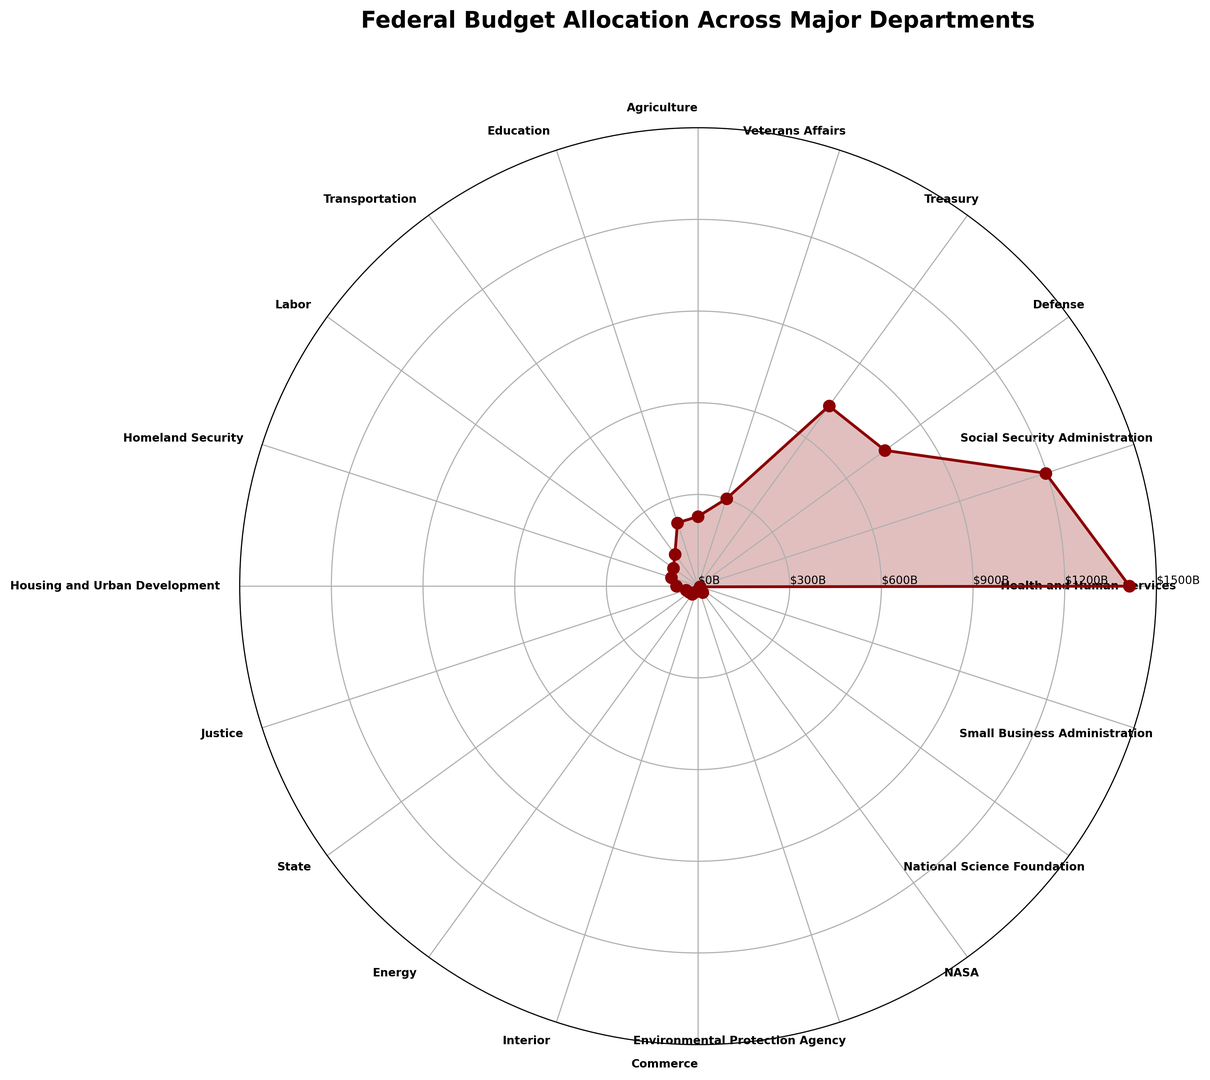Which department has the highest budget allocation? By examining the plot, the department with the largest radial segment will have the highest budget allocation. Health and Human Services has the biggest segment.
Answer: Health and Human Services How does the budget of the Defense department compare to that of the Treasury? Locate both Defense and Treasury segments in the plot and compare their lengths. The Defense radial segment is slightly longer than Treasury's.
Answer: Defense is greater Which two departments have the smallest budget allocations? Look for the smallest radial segments, which represent the smallest budget allocations. Commerce and Small Business Administration have the smallest segments.
Answer: Commerce and Small Business Administration What is the combined budget allocation for Health and Human Services and Social Security Administration? Sum the budget allocations for Health and Human Services ($1412B) and Social Security Administration ($1196B). 1412 + 1196 = 2608
Answer: 2608 billion Which departments have a budget allocation between $200B and $300B? Identify the segments between 200B and 300B on the radial axis. Agriculture ($228B), Education ($218B), and Veterans Affairs ($301B, slightly above $300B).
Answer: Agriculture, Education, and Veterans Affairs How much more is allocated to Defense compared to Homeland Security? Subtract the budget allocation of Homeland Security ($92B) from Defense's ($756B). 756 - 92 = 664
Answer: 664 billion Arrange the top four departments by budget allocation in descending order. The top four departments can be identified by the longest segments. They are Health and Human Services, Social Security Administration, Defense, and Treasury.
Answer: Health and Human Services, Social Security Administration, Defense, Treasury What is the average budget allocated to Education, Transportation, and Labor? Sum the budget allocations for Education ($218B), Transportation ($129B), and Labor ($100B), then divide by 3. (218 + 129 + 100) / 3 = 147
Answer: 147 billion Which department has a budget closest to $100B? Observe the radial segments around the $100B mark. Labor has a budget of $100B.
Answer: Labor Calculate the total budget allocation for departments with allocations under $50B. Sum the budget allocations for Justice ($41B), State ($35B), Energy ($32B), Interior ($18B), Commerce ($16B), Environmental Protection Agency ($11B), National Science Foundation ($9B), Small Business Administration ($7B). (41 + 35 + 32 + 18 + 16 + 11 + 9 + 7) = 169
Answer: 169 billion 